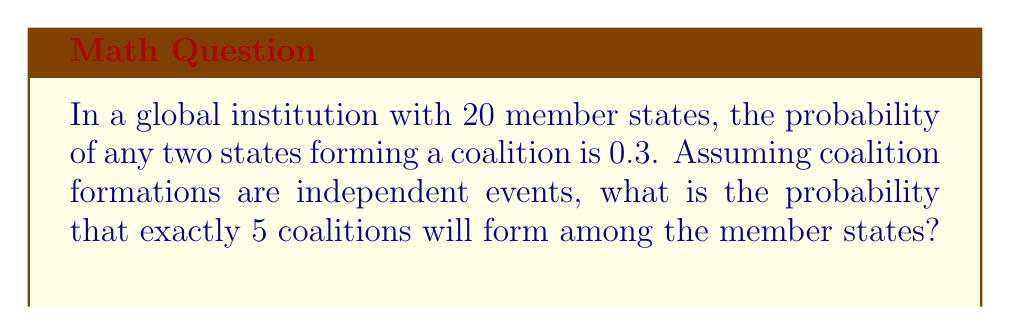Could you help me with this problem? To solve this problem, we need to use the binomial probability distribution. Here's a step-by-step explanation:

1. Identify the parameters:
   - $n$ = total number of possible coalitions
   - $p$ = probability of a coalition forming
   - $k$ = number of coalitions we want to form

2. Calculate the total number of possible coalitions:
   $$n = \binom{20}{2} = \frac{20!}{2!(20-2)!} = 190$$

3. We know:
   - $n = 190$
   - $p = 0.3$
   - $k = 5$

4. Use the binomial probability formula:

   $$P(X = k) = \binom{n}{k} p^k (1-p)^{n-k}$$

5. Substitute the values:

   $$P(X = 5) = \binom{190}{5} (0.3)^5 (1-0.3)^{190-5}$$

6. Calculate:
   $$\begin{aligned}
   P(X = 5) &= 1,711,630,020 \times (0.3)^5 \times (0.7)^{185} \\
   &= 1,711,630,020 \times 0.00243 \times 1.8693 \times 10^{-24} \\
   &\approx 0.00777
   \end{aligned}$$
Answer: The probability of exactly 5 coalitions forming among the 20 member states is approximately 0.00777 or 0.777%. 